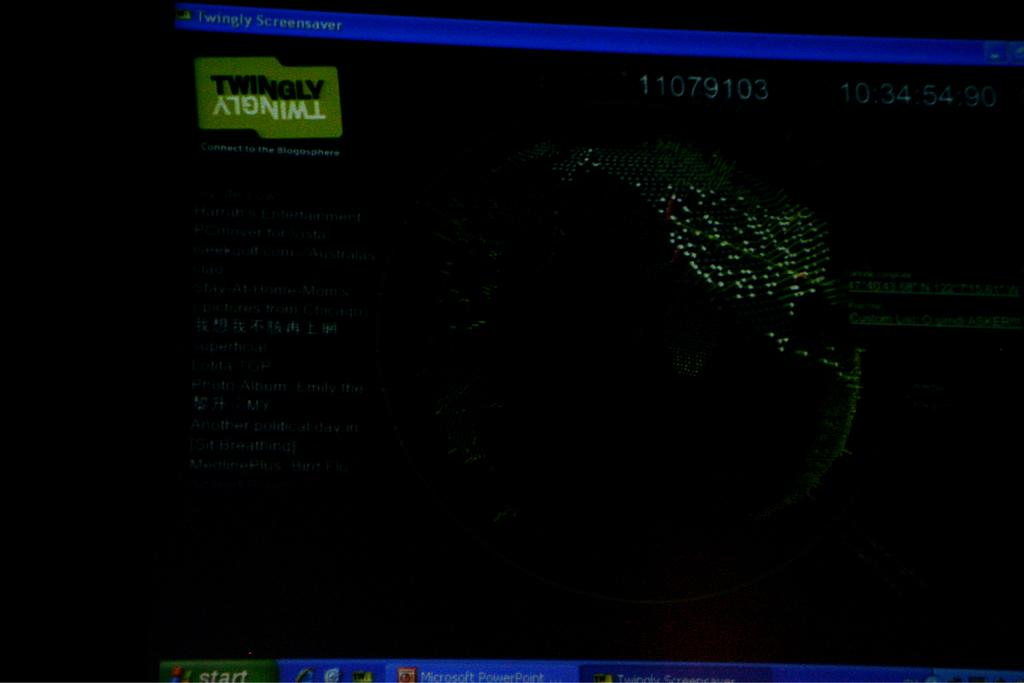<image>
Write a terse but informative summary of the picture. a dark computer screen with the word twingly at the top right corner 